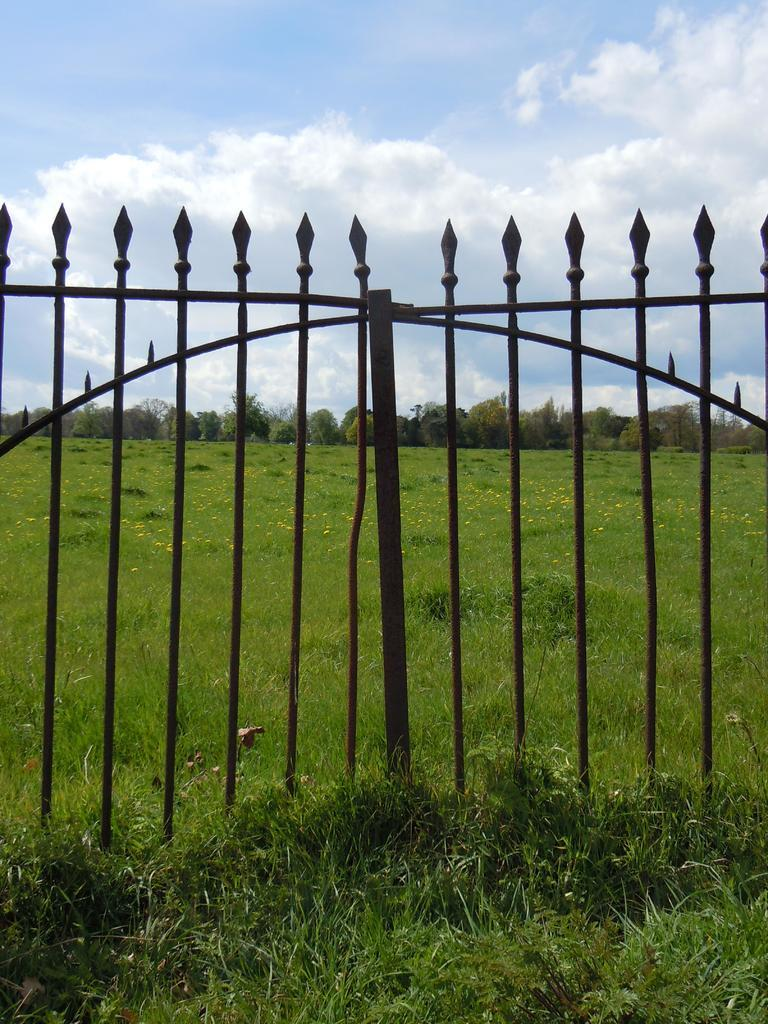What type of terrain is visible in the image? There is a grassy land in the image. What natural elements can be seen in the image? There are many trees in the image. What type of barrier is present in the image? There is fencing in the image. How would you describe the sky in the image? The sky is blue and cloudy in the image. What type of plastic objects can be seen scattered on the grassy land in the image? There are no plastic objects visible in the image; it features a grassy land with trees and fencing. 